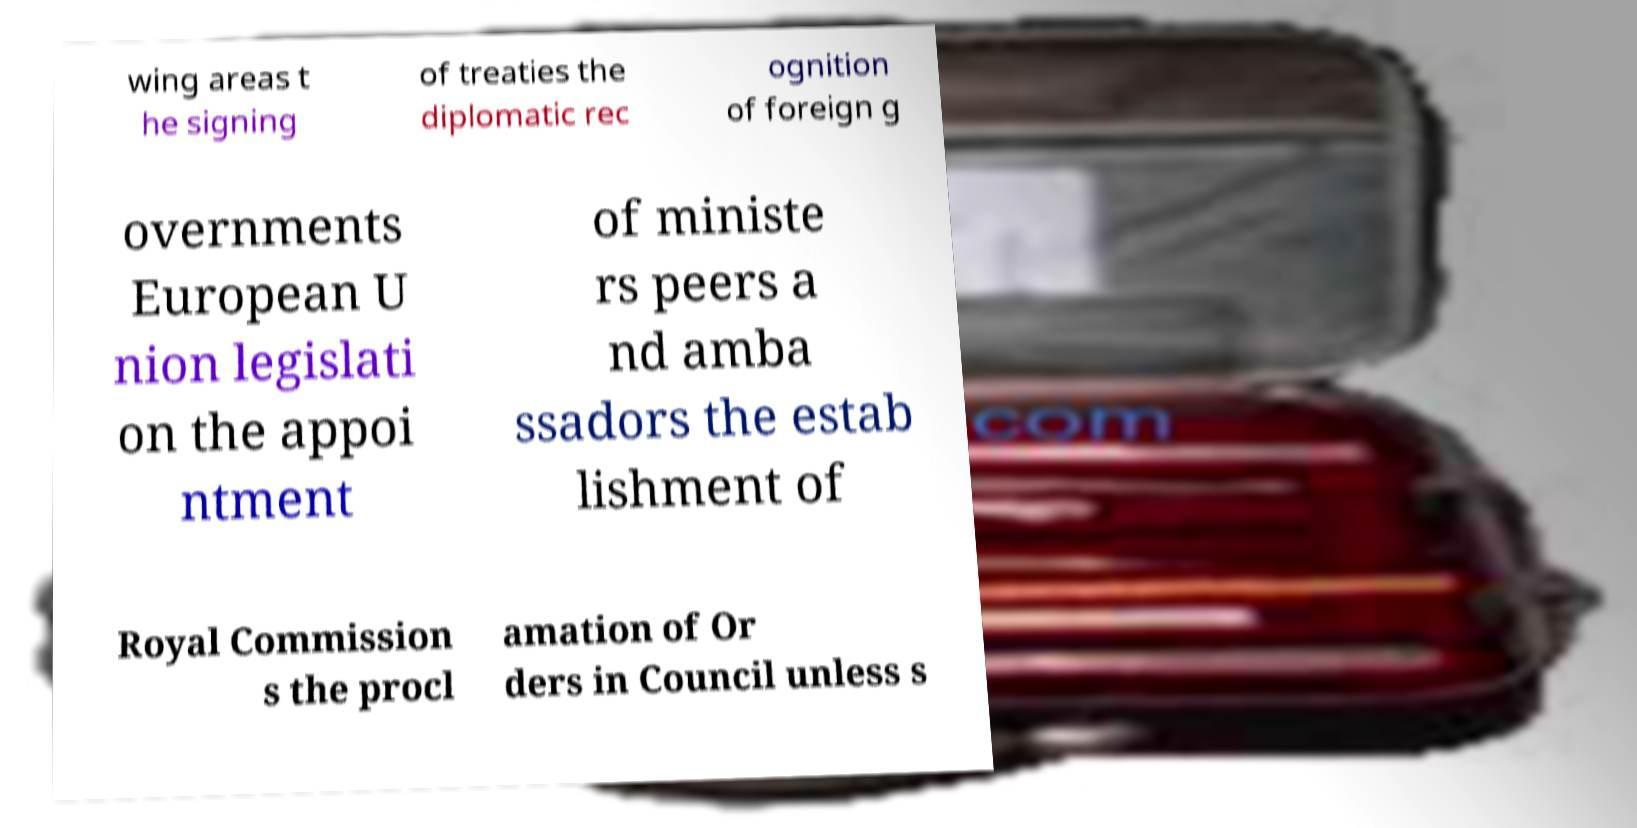Can you accurately transcribe the text from the provided image for me? wing areas t he signing of treaties the diplomatic rec ognition of foreign g overnments European U nion legislati on the appoi ntment of ministe rs peers a nd amba ssadors the estab lishment of Royal Commission s the procl amation of Or ders in Council unless s 